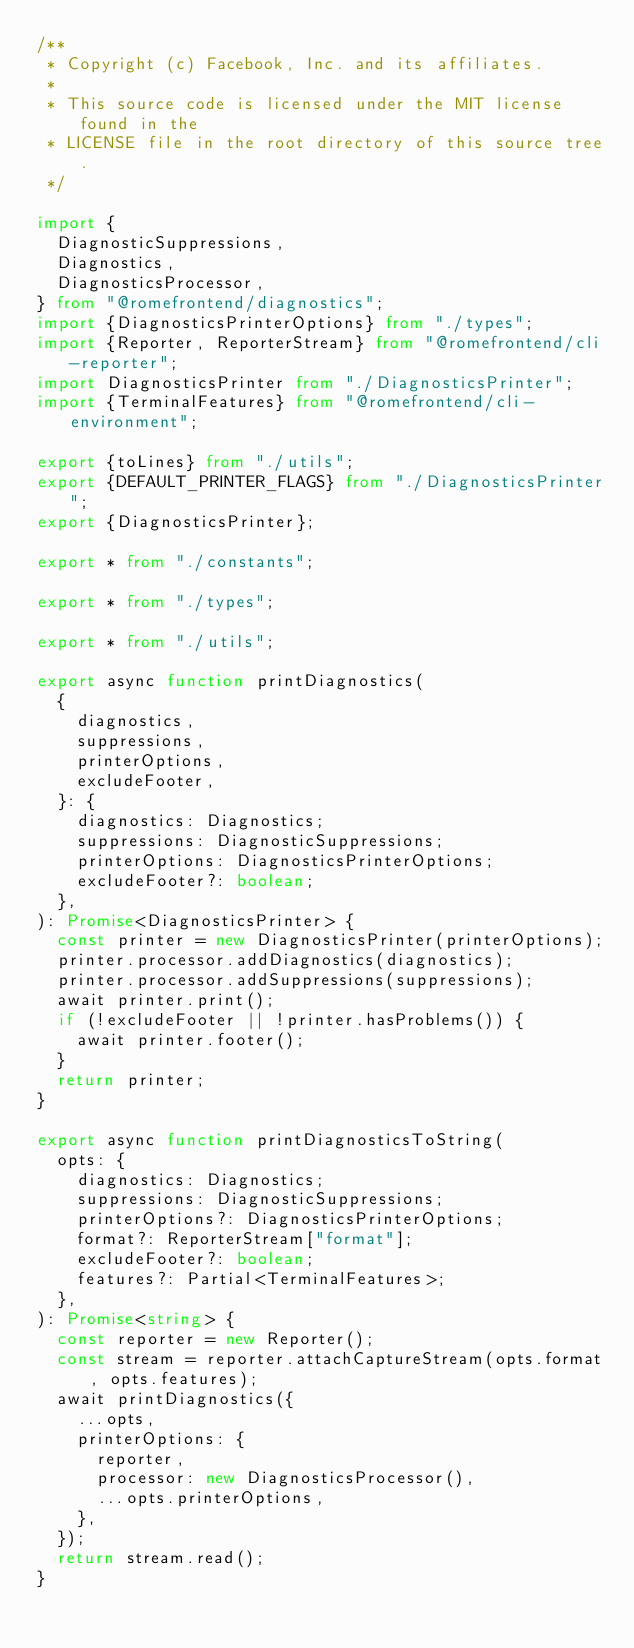<code> <loc_0><loc_0><loc_500><loc_500><_TypeScript_>/**
 * Copyright (c) Facebook, Inc. and its affiliates.
 *
 * This source code is licensed under the MIT license found in the
 * LICENSE file in the root directory of this source tree.
 */

import {
	DiagnosticSuppressions,
	Diagnostics,
	DiagnosticsProcessor,
} from "@romefrontend/diagnostics";
import {DiagnosticsPrinterOptions} from "./types";
import {Reporter, ReporterStream} from "@romefrontend/cli-reporter";
import DiagnosticsPrinter from "./DiagnosticsPrinter";
import {TerminalFeatures} from "@romefrontend/cli-environment";

export {toLines} from "./utils";
export {DEFAULT_PRINTER_FLAGS} from "./DiagnosticsPrinter";
export {DiagnosticsPrinter};

export * from "./constants";

export * from "./types";

export * from "./utils";

export async function printDiagnostics(
	{
		diagnostics,
		suppressions,
		printerOptions,
		excludeFooter,
	}: {
		diagnostics: Diagnostics;
		suppressions: DiagnosticSuppressions;
		printerOptions: DiagnosticsPrinterOptions;
		excludeFooter?: boolean;
	},
): Promise<DiagnosticsPrinter> {
	const printer = new DiagnosticsPrinter(printerOptions);
	printer.processor.addDiagnostics(diagnostics);
	printer.processor.addSuppressions(suppressions);
	await printer.print();
	if (!excludeFooter || !printer.hasProblems()) {
		await printer.footer();
	}
	return printer;
}

export async function printDiagnosticsToString(
	opts: {
		diagnostics: Diagnostics;
		suppressions: DiagnosticSuppressions;
		printerOptions?: DiagnosticsPrinterOptions;
		format?: ReporterStream["format"];
		excludeFooter?: boolean;
		features?: Partial<TerminalFeatures>;
	},
): Promise<string> {
	const reporter = new Reporter();
	const stream = reporter.attachCaptureStream(opts.format, opts.features);
	await printDiagnostics({
		...opts,
		printerOptions: {
			reporter,
			processor: new DiagnosticsProcessor(),
			...opts.printerOptions,
		},
	});
	return stream.read();
}
</code> 